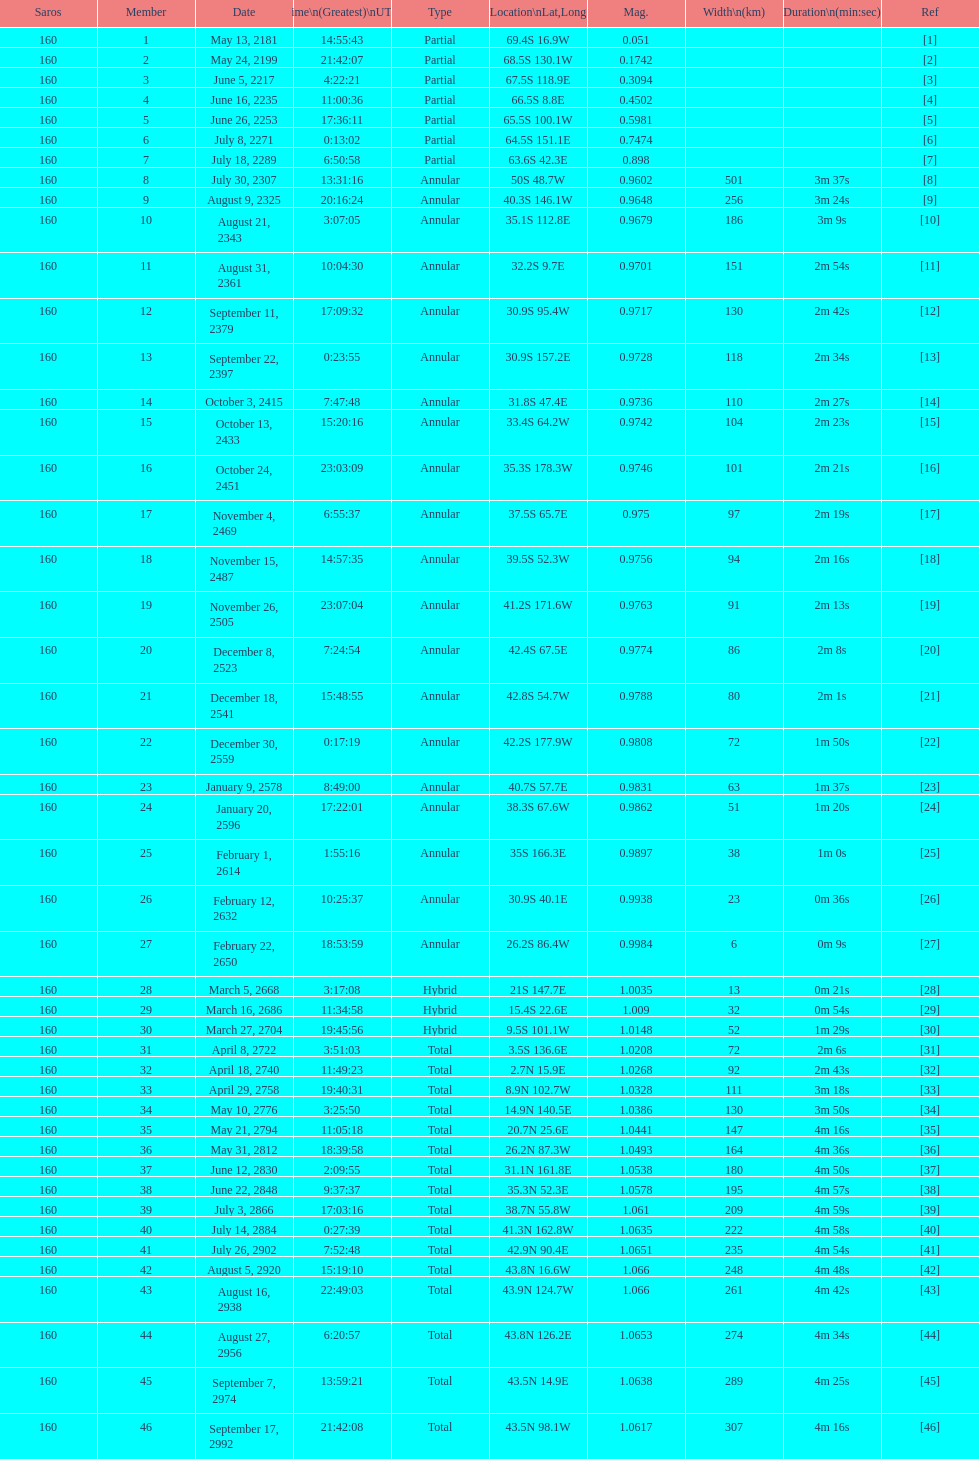How long did 18 last? 2m 16s. 